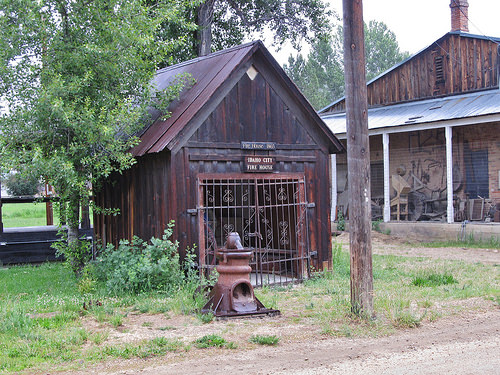<image>
Can you confirm if the tree is behind the post? Yes. From this viewpoint, the tree is positioned behind the post, with the post partially or fully occluding the tree. Where is the sky in relation to the house? Is it behind the house? Yes. From this viewpoint, the sky is positioned behind the house, with the house partially or fully occluding the sky. 